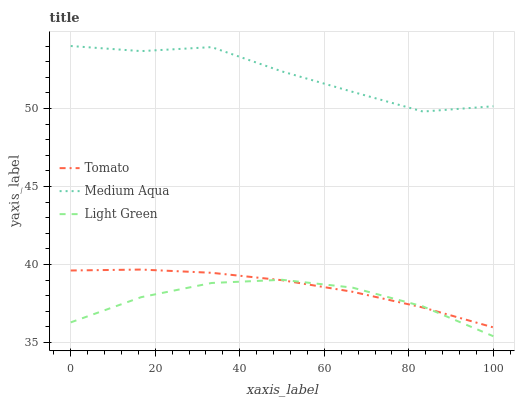Does Light Green have the minimum area under the curve?
Answer yes or no. Yes. Does Medium Aqua have the maximum area under the curve?
Answer yes or no. Yes. Does Medium Aqua have the minimum area under the curve?
Answer yes or no. No. Does Light Green have the maximum area under the curve?
Answer yes or no. No. Is Tomato the smoothest?
Answer yes or no. Yes. Is Medium Aqua the roughest?
Answer yes or no. Yes. Is Light Green the smoothest?
Answer yes or no. No. Is Light Green the roughest?
Answer yes or no. No. Does Light Green have the lowest value?
Answer yes or no. Yes. Does Medium Aqua have the lowest value?
Answer yes or no. No. Does Medium Aqua have the highest value?
Answer yes or no. Yes. Does Light Green have the highest value?
Answer yes or no. No. Is Tomato less than Medium Aqua?
Answer yes or no. Yes. Is Medium Aqua greater than Tomato?
Answer yes or no. Yes. Does Light Green intersect Tomato?
Answer yes or no. Yes. Is Light Green less than Tomato?
Answer yes or no. No. Is Light Green greater than Tomato?
Answer yes or no. No. Does Tomato intersect Medium Aqua?
Answer yes or no. No. 